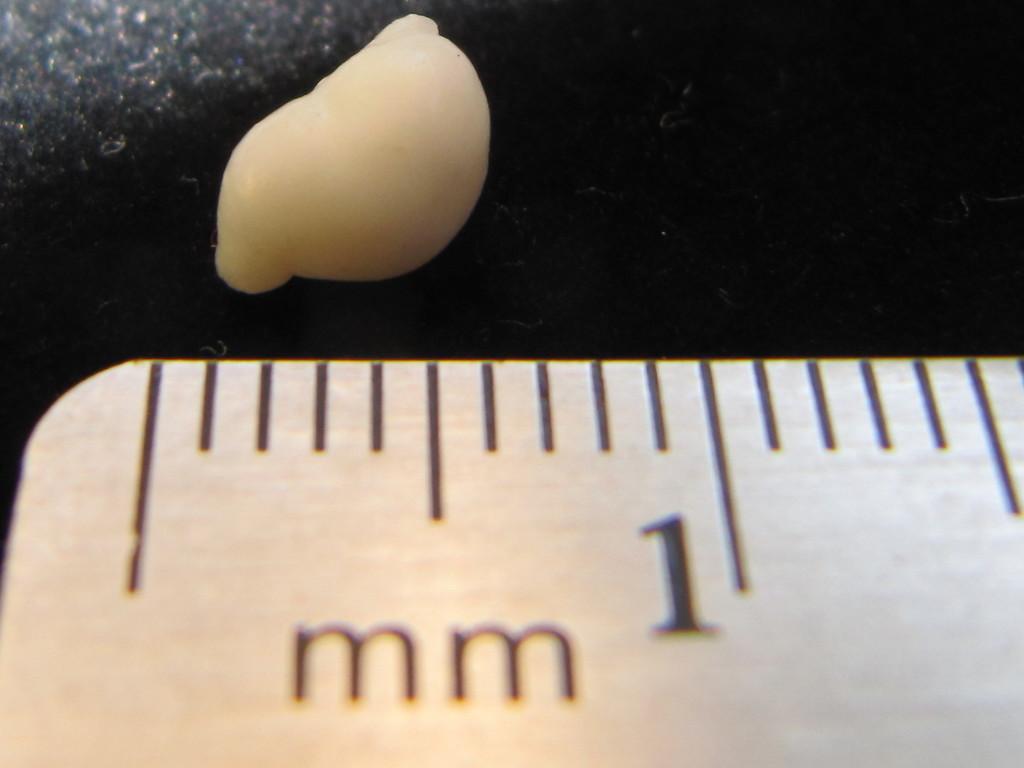What many mm is this ?
Give a very brief answer. 1. What system of measurement is this ruler using?
Provide a succinct answer. Mm. 